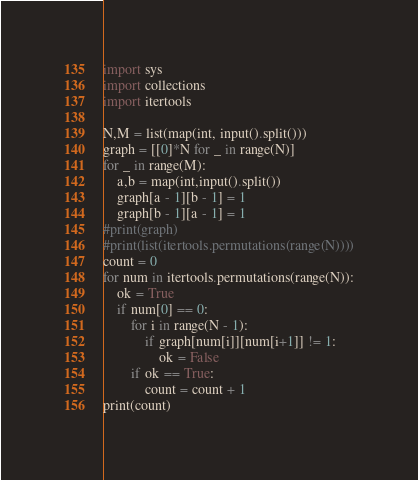Convert code to text. <code><loc_0><loc_0><loc_500><loc_500><_Python_>import sys
import collections
import itertools

N,M = list(map(int, input().split()))
graph = [[0]*N for _ in range(N)]
for _ in range(M):
    a,b = map(int,input().split())
    graph[a - 1][b - 1] = 1
    graph[b - 1][a - 1] = 1
#print(graph)
#print(list(itertools.permutations(range(N))))
count = 0
for num in itertools.permutations(range(N)):
    ok = True
    if num[0] == 0:
        for i in range(N - 1):
            if graph[num[i]][num[i+1]] != 1:
                ok = False
        if ok == True:
            count = count + 1
print(count)
</code> 